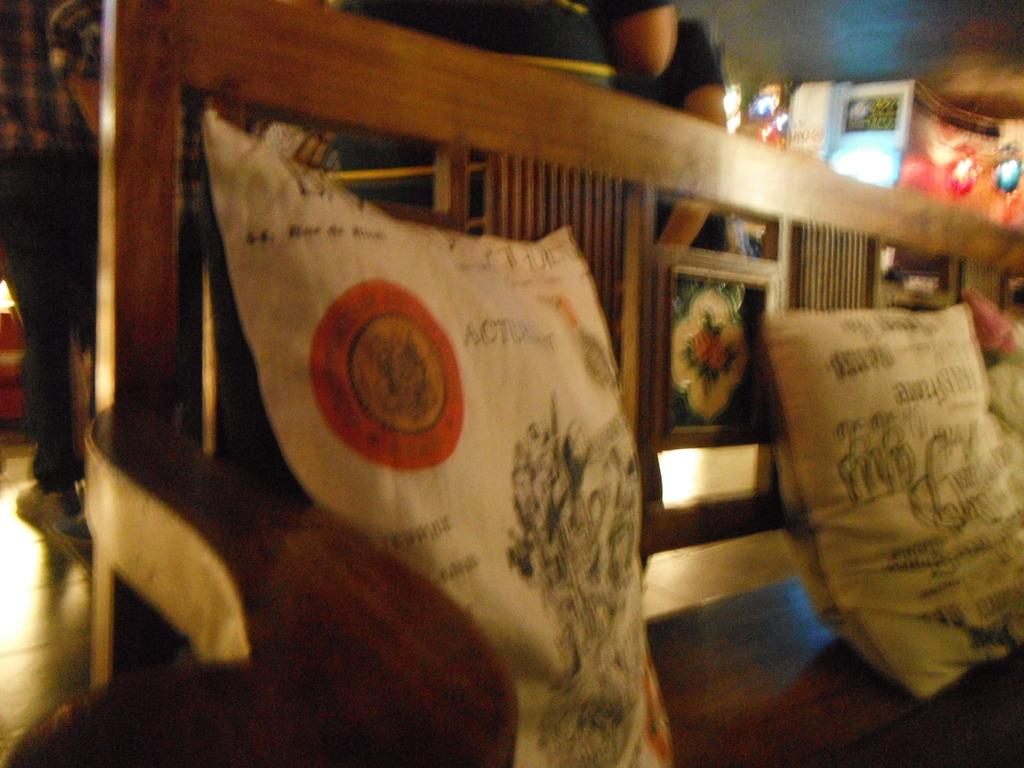How many pillows are visible in the image? There are two pillows in the image. Where are the pillows located? The pillows are on a wooden bench chair. What type of soda is being poured onto the pillows in the image? There is no soda present in the image; it only features two pillows on a wooden bench chair. 